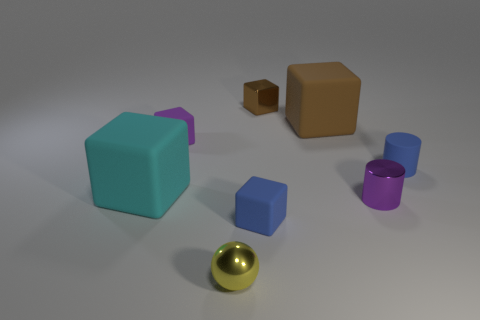Do the brown matte thing and the tiny blue rubber thing that is in front of the purple cylinder have the same shape?
Your answer should be compact. Yes. What number of blue objects have the same size as the blue cylinder?
Make the answer very short. 1. There is a tiny brown object that is the same shape as the big cyan rubber object; what material is it?
Offer a terse response. Metal. Do the metallic thing behind the large cyan cube and the large matte cube that is right of the cyan cube have the same color?
Offer a very short reply. Yes. What is the shape of the tiny purple thing that is in front of the cyan cube?
Keep it short and to the point. Cylinder. The rubber cylinder has what color?
Keep it short and to the point. Blue. There is another big object that is the same material as the large brown thing; what shape is it?
Provide a succinct answer. Cube. Is the size of the purple thing left of the yellow metal ball the same as the tiny brown cube?
Provide a short and direct response. Yes. What number of things are either cubes behind the brown matte thing or tiny metal objects behind the small sphere?
Make the answer very short. 2. Is the color of the tiny rubber cube that is to the right of the tiny yellow object the same as the small rubber cylinder?
Make the answer very short. Yes. 